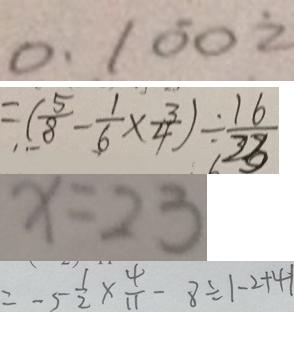<formula> <loc_0><loc_0><loc_500><loc_500>0 . 1 \dot { 0 } 0 \dot { 2 } 
 = ( \frac { 5 } { 8 } - \frac { 1 } { 6 } \times \frac { 3 } { 4 } ) \div \frac { 1 6 } { 2 3 } 
 x = 2 3 
 = - 5 \frac { 1 } { 2 } \times \frac { 4 } { 1 1 } - 8 \div \vert - 2 + 4 \vert</formula> 